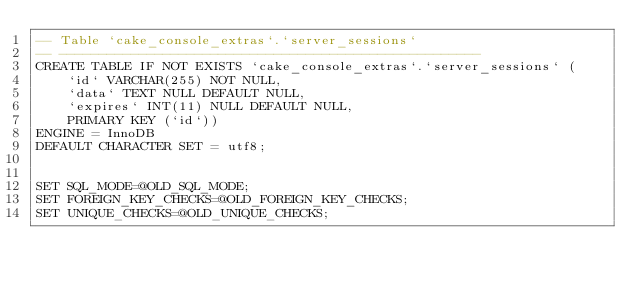<code> <loc_0><loc_0><loc_500><loc_500><_SQL_>-- Table `cake_console_extras`.`server_sessions`
-- -----------------------------------------------------
CREATE TABLE IF NOT EXISTS `cake_console_extras`.`server_sessions` (
    `id` VARCHAR(255) NOT NULL, 
    `data` TEXT NULL DEFAULT NULL, 
    `expires` INT(11) NULL DEFAULT NULL, 
    PRIMARY KEY (`id`))
ENGINE = InnoDB
DEFAULT CHARACTER SET = utf8;


SET SQL_MODE=@OLD_SQL_MODE;
SET FOREIGN_KEY_CHECKS=@OLD_FOREIGN_KEY_CHECKS;
SET UNIQUE_CHECKS=@OLD_UNIQUE_CHECKS;
</code> 